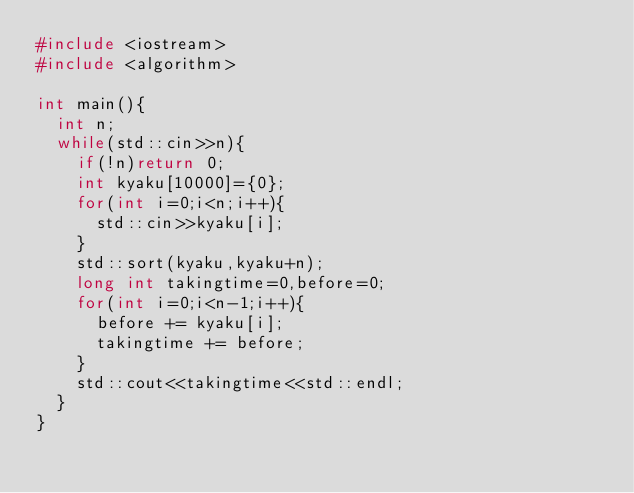<code> <loc_0><loc_0><loc_500><loc_500><_C++_>#include <iostream>
#include <algorithm>

int main(){
  int n;
  while(std::cin>>n){
    if(!n)return 0;
    int kyaku[10000]={0};
    for(int i=0;i<n;i++){
      std::cin>>kyaku[i];
    }
    std::sort(kyaku,kyaku+n);
    long int takingtime=0,before=0;
    for(int i=0;i<n-1;i++){
      before += kyaku[i];
      takingtime += before;
    }
    std::cout<<takingtime<<std::endl;
  }
}</code> 